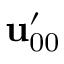<formula> <loc_0><loc_0><loc_500><loc_500>u _ { 0 0 } ^ { \prime }</formula> 